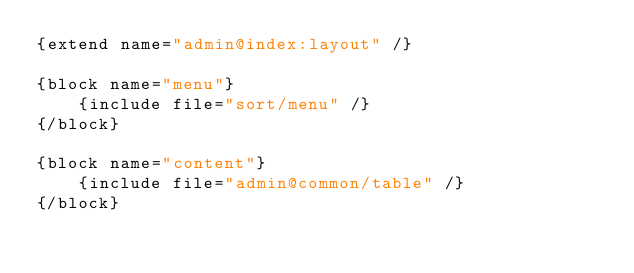<code> <loc_0><loc_0><loc_500><loc_500><_HTML_>{extend name="admin@index:layout" /}

{block name="menu"}
	{include file="sort/menu" /} 
{/block}

{block name="content"}
	{include file="admin@common/table" /}
{/block}</code> 